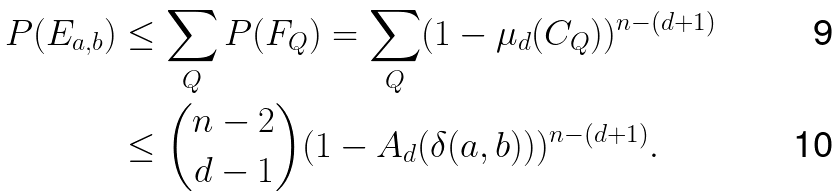Convert formula to latex. <formula><loc_0><loc_0><loc_500><loc_500>P ( E _ { a , b } ) & \leq \sum _ { Q } P ( F _ { Q } ) = \sum _ { Q } ( 1 - \mu _ { d } ( C _ { Q } ) ) ^ { n - ( d + 1 ) } \\ & \leq \binom { n - 2 } { d - 1 } ( 1 - A _ { d } ( \delta ( a , b ) ) ) ^ { n - ( d + 1 ) } .</formula> 